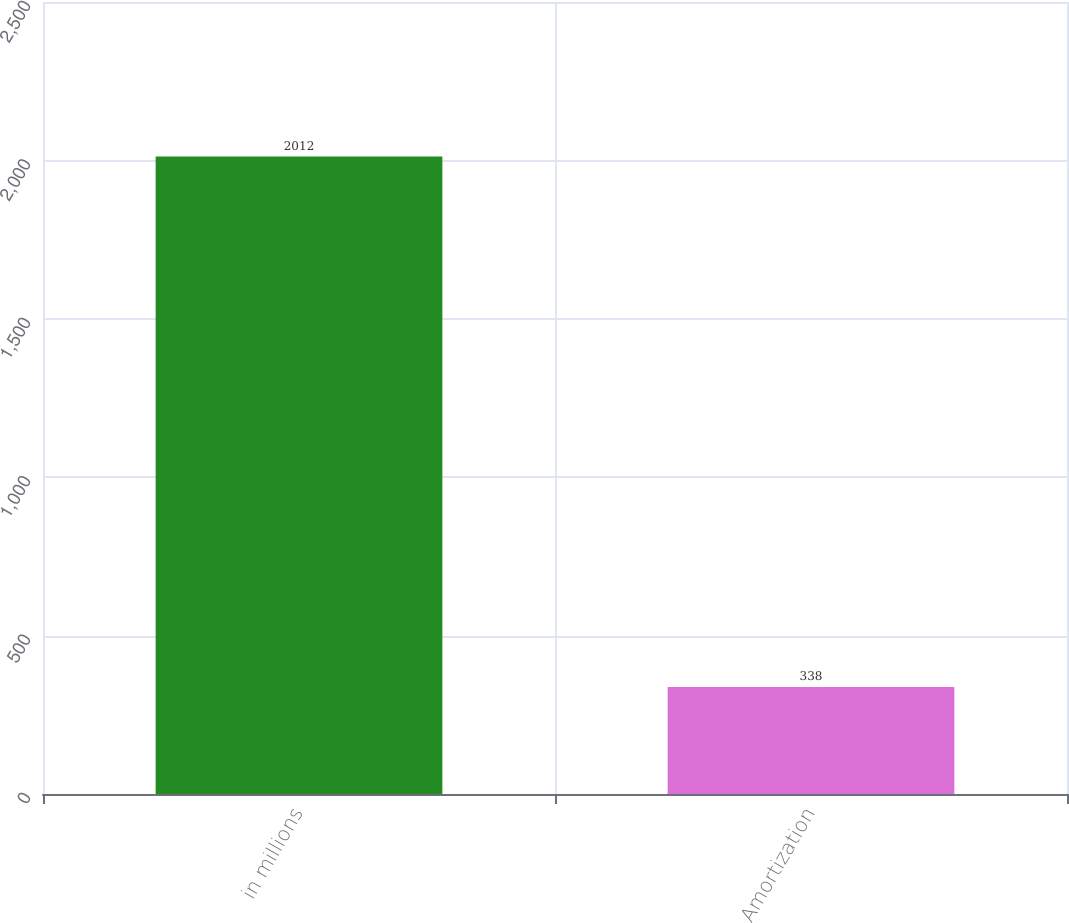Convert chart. <chart><loc_0><loc_0><loc_500><loc_500><bar_chart><fcel>in millions<fcel>Amortization<nl><fcel>2012<fcel>338<nl></chart> 